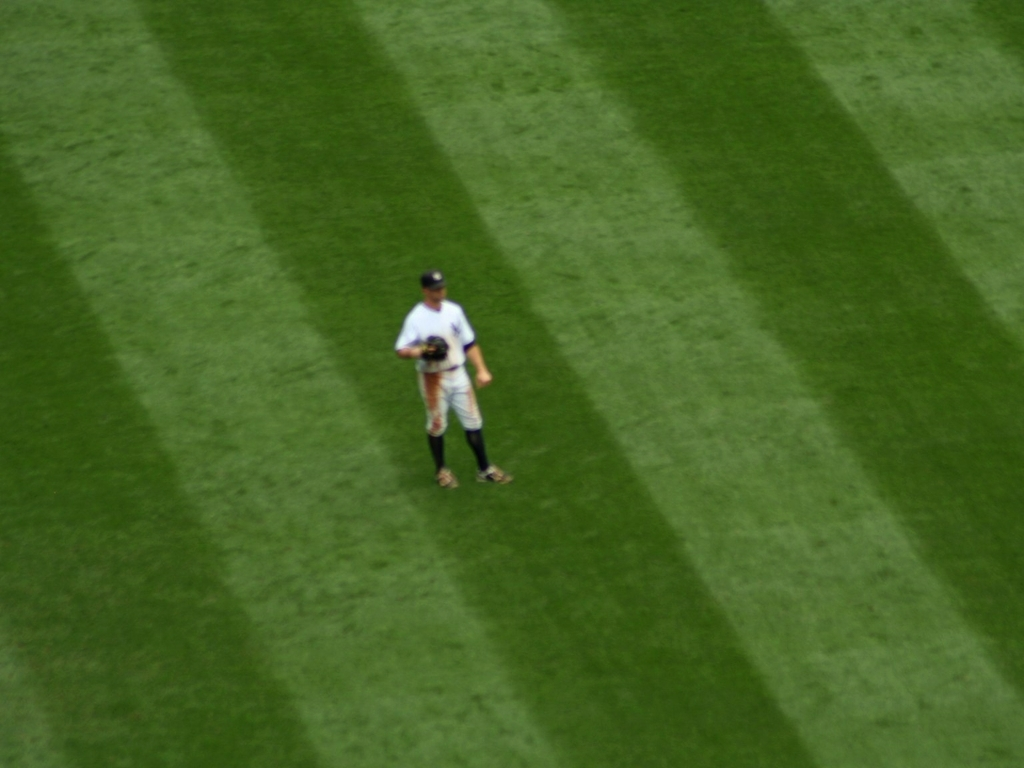What could be the reason for the shadow patterns on the field, and how do they affect the visibility of the person in the image? The shadow patterns on the field are likely from stadium lights or structures interrupting sunlight, creating alternating areas of light and shade. These patterns can enhance the three-dimensional impression of the image by providing depth cues. However, they also influence the visibility of the person, causing some parts of the figure to merge with shadowed areas, potentially obscuring certain details. 